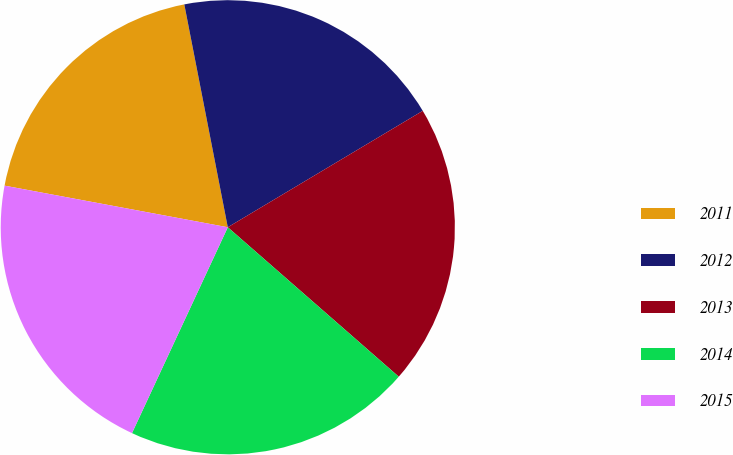<chart> <loc_0><loc_0><loc_500><loc_500><pie_chart><fcel>2011<fcel>2012<fcel>2013<fcel>2014<fcel>2015<nl><fcel>19.0%<fcel>19.5%<fcel>20.0%<fcel>20.5%<fcel>21.0%<nl></chart> 